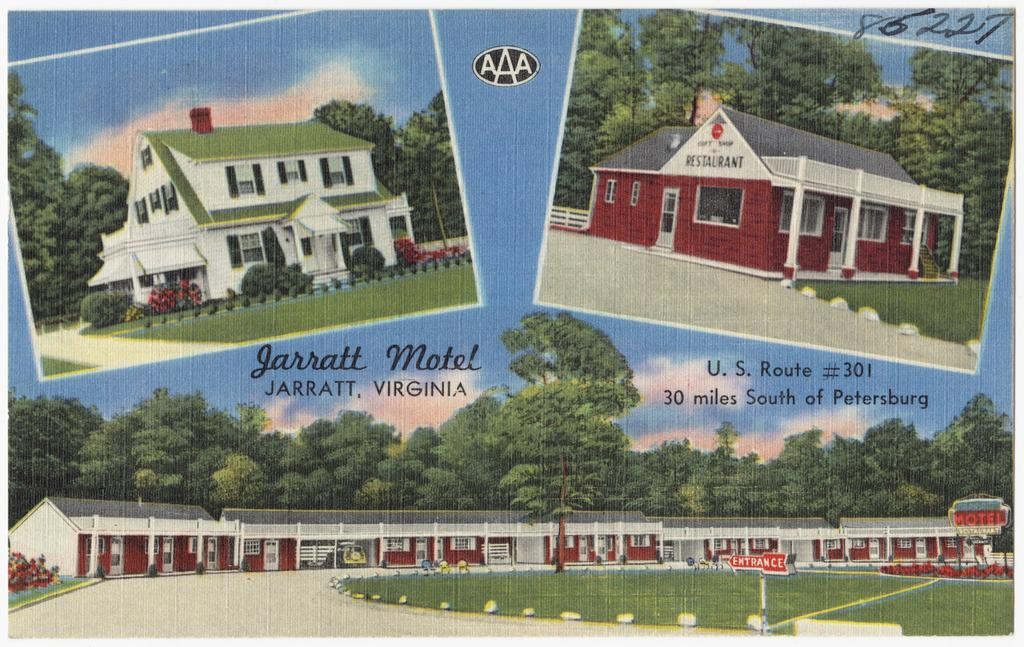What is featured in the image? There is a poster in the image. What is depicted on the poster? The poster depicts roof houses, trees, a path, and the sky. What can be seen in the sky on the poster? Clouds are present in the sky on the poster. Where is the text and numbers located in the image? They are in the top right corner of the image. What type of plastic is being used by the dinosaurs in the image? There are no dinosaurs present in the image, so it is not possible to determine what type of plastic they might be using. 